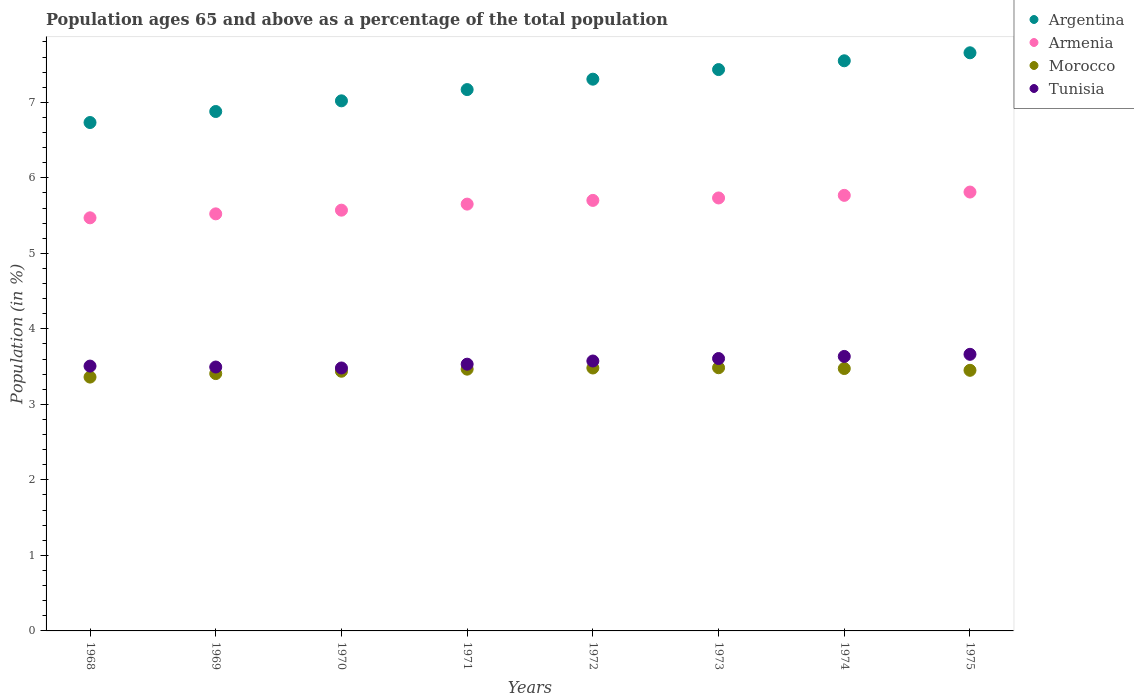What is the percentage of the population ages 65 and above in Argentina in 1972?
Offer a very short reply. 7.31. Across all years, what is the maximum percentage of the population ages 65 and above in Armenia?
Offer a terse response. 5.81. Across all years, what is the minimum percentage of the population ages 65 and above in Tunisia?
Provide a succinct answer. 3.48. In which year was the percentage of the population ages 65 and above in Morocco maximum?
Offer a terse response. 1973. In which year was the percentage of the population ages 65 and above in Tunisia minimum?
Offer a terse response. 1970. What is the total percentage of the population ages 65 and above in Argentina in the graph?
Provide a succinct answer. 57.75. What is the difference between the percentage of the population ages 65 and above in Armenia in 1973 and that in 1975?
Your answer should be very brief. -0.08. What is the difference between the percentage of the population ages 65 and above in Morocco in 1973 and the percentage of the population ages 65 and above in Argentina in 1975?
Make the answer very short. -4.17. What is the average percentage of the population ages 65 and above in Tunisia per year?
Ensure brevity in your answer.  3.56. In the year 1973, what is the difference between the percentage of the population ages 65 and above in Morocco and percentage of the population ages 65 and above in Armenia?
Provide a short and direct response. -2.25. In how many years, is the percentage of the population ages 65 and above in Armenia greater than 6.8?
Give a very brief answer. 0. What is the ratio of the percentage of the population ages 65 and above in Tunisia in 1971 to that in 1974?
Offer a very short reply. 0.97. Is the difference between the percentage of the population ages 65 and above in Morocco in 1970 and 1973 greater than the difference between the percentage of the population ages 65 and above in Armenia in 1970 and 1973?
Make the answer very short. Yes. What is the difference between the highest and the second highest percentage of the population ages 65 and above in Morocco?
Give a very brief answer. 0. What is the difference between the highest and the lowest percentage of the population ages 65 and above in Morocco?
Your answer should be compact. 0.12. Is it the case that in every year, the sum of the percentage of the population ages 65 and above in Armenia and percentage of the population ages 65 and above in Argentina  is greater than the sum of percentage of the population ages 65 and above in Morocco and percentage of the population ages 65 and above in Tunisia?
Offer a terse response. Yes. Does the percentage of the population ages 65 and above in Armenia monotonically increase over the years?
Your answer should be very brief. Yes. Is the percentage of the population ages 65 and above in Tunisia strictly greater than the percentage of the population ages 65 and above in Morocco over the years?
Make the answer very short. Yes. How many years are there in the graph?
Provide a succinct answer. 8. Does the graph contain any zero values?
Your answer should be compact. No. What is the title of the graph?
Make the answer very short. Population ages 65 and above as a percentage of the total population. Does "Malta" appear as one of the legend labels in the graph?
Ensure brevity in your answer.  No. What is the label or title of the Y-axis?
Ensure brevity in your answer.  Population (in %). What is the Population (in %) in Argentina in 1968?
Your answer should be very brief. 6.73. What is the Population (in %) in Armenia in 1968?
Ensure brevity in your answer.  5.47. What is the Population (in %) in Morocco in 1968?
Offer a terse response. 3.36. What is the Population (in %) of Tunisia in 1968?
Your response must be concise. 3.51. What is the Population (in %) in Argentina in 1969?
Provide a succinct answer. 6.88. What is the Population (in %) in Armenia in 1969?
Your response must be concise. 5.52. What is the Population (in %) in Morocco in 1969?
Your response must be concise. 3.41. What is the Population (in %) of Tunisia in 1969?
Offer a very short reply. 3.49. What is the Population (in %) of Argentina in 1970?
Your answer should be compact. 7.02. What is the Population (in %) of Armenia in 1970?
Offer a terse response. 5.57. What is the Population (in %) of Morocco in 1970?
Ensure brevity in your answer.  3.44. What is the Population (in %) in Tunisia in 1970?
Offer a very short reply. 3.48. What is the Population (in %) in Argentina in 1971?
Make the answer very short. 7.17. What is the Population (in %) of Armenia in 1971?
Offer a terse response. 5.65. What is the Population (in %) in Morocco in 1971?
Ensure brevity in your answer.  3.47. What is the Population (in %) in Tunisia in 1971?
Provide a short and direct response. 3.53. What is the Population (in %) of Argentina in 1972?
Your response must be concise. 7.31. What is the Population (in %) in Armenia in 1972?
Make the answer very short. 5.7. What is the Population (in %) of Morocco in 1972?
Ensure brevity in your answer.  3.48. What is the Population (in %) of Tunisia in 1972?
Offer a terse response. 3.57. What is the Population (in %) in Argentina in 1973?
Your response must be concise. 7.43. What is the Population (in %) in Armenia in 1973?
Your answer should be very brief. 5.73. What is the Population (in %) of Morocco in 1973?
Your answer should be very brief. 3.49. What is the Population (in %) of Tunisia in 1973?
Offer a terse response. 3.61. What is the Population (in %) of Argentina in 1974?
Offer a very short reply. 7.55. What is the Population (in %) in Armenia in 1974?
Offer a very short reply. 5.77. What is the Population (in %) in Morocco in 1974?
Your answer should be very brief. 3.47. What is the Population (in %) of Tunisia in 1974?
Your answer should be very brief. 3.63. What is the Population (in %) in Argentina in 1975?
Offer a very short reply. 7.66. What is the Population (in %) of Armenia in 1975?
Ensure brevity in your answer.  5.81. What is the Population (in %) in Morocco in 1975?
Ensure brevity in your answer.  3.45. What is the Population (in %) in Tunisia in 1975?
Offer a very short reply. 3.66. Across all years, what is the maximum Population (in %) of Argentina?
Offer a very short reply. 7.66. Across all years, what is the maximum Population (in %) of Armenia?
Give a very brief answer. 5.81. Across all years, what is the maximum Population (in %) of Morocco?
Keep it short and to the point. 3.49. Across all years, what is the maximum Population (in %) in Tunisia?
Provide a succinct answer. 3.66. Across all years, what is the minimum Population (in %) of Argentina?
Make the answer very short. 6.73. Across all years, what is the minimum Population (in %) of Armenia?
Offer a very short reply. 5.47. Across all years, what is the minimum Population (in %) in Morocco?
Offer a terse response. 3.36. Across all years, what is the minimum Population (in %) in Tunisia?
Keep it short and to the point. 3.48. What is the total Population (in %) in Argentina in the graph?
Offer a very short reply. 57.75. What is the total Population (in %) of Armenia in the graph?
Your answer should be very brief. 45.23. What is the total Population (in %) of Morocco in the graph?
Your response must be concise. 27.57. What is the total Population (in %) of Tunisia in the graph?
Offer a very short reply. 28.5. What is the difference between the Population (in %) in Argentina in 1968 and that in 1969?
Make the answer very short. -0.15. What is the difference between the Population (in %) of Armenia in 1968 and that in 1969?
Give a very brief answer. -0.05. What is the difference between the Population (in %) in Morocco in 1968 and that in 1969?
Your answer should be very brief. -0.05. What is the difference between the Population (in %) of Tunisia in 1968 and that in 1969?
Your answer should be compact. 0.01. What is the difference between the Population (in %) in Argentina in 1968 and that in 1970?
Provide a short and direct response. -0.29. What is the difference between the Population (in %) in Armenia in 1968 and that in 1970?
Your response must be concise. -0.1. What is the difference between the Population (in %) in Morocco in 1968 and that in 1970?
Your response must be concise. -0.08. What is the difference between the Population (in %) in Tunisia in 1968 and that in 1970?
Your response must be concise. 0.03. What is the difference between the Population (in %) in Argentina in 1968 and that in 1971?
Give a very brief answer. -0.44. What is the difference between the Population (in %) of Armenia in 1968 and that in 1971?
Your response must be concise. -0.18. What is the difference between the Population (in %) of Morocco in 1968 and that in 1971?
Your response must be concise. -0.11. What is the difference between the Population (in %) in Tunisia in 1968 and that in 1971?
Keep it short and to the point. -0.03. What is the difference between the Population (in %) of Argentina in 1968 and that in 1972?
Ensure brevity in your answer.  -0.57. What is the difference between the Population (in %) in Armenia in 1968 and that in 1972?
Your answer should be compact. -0.23. What is the difference between the Population (in %) of Morocco in 1968 and that in 1972?
Offer a very short reply. -0.12. What is the difference between the Population (in %) in Tunisia in 1968 and that in 1972?
Offer a terse response. -0.07. What is the difference between the Population (in %) of Argentina in 1968 and that in 1973?
Make the answer very short. -0.7. What is the difference between the Population (in %) of Armenia in 1968 and that in 1973?
Provide a succinct answer. -0.26. What is the difference between the Population (in %) of Morocco in 1968 and that in 1973?
Your answer should be very brief. -0.12. What is the difference between the Population (in %) of Tunisia in 1968 and that in 1973?
Provide a succinct answer. -0.1. What is the difference between the Population (in %) in Argentina in 1968 and that in 1974?
Give a very brief answer. -0.82. What is the difference between the Population (in %) in Armenia in 1968 and that in 1974?
Your answer should be compact. -0.3. What is the difference between the Population (in %) of Morocco in 1968 and that in 1974?
Offer a very short reply. -0.11. What is the difference between the Population (in %) in Tunisia in 1968 and that in 1974?
Make the answer very short. -0.13. What is the difference between the Population (in %) in Argentina in 1968 and that in 1975?
Ensure brevity in your answer.  -0.92. What is the difference between the Population (in %) of Armenia in 1968 and that in 1975?
Provide a succinct answer. -0.34. What is the difference between the Population (in %) in Morocco in 1968 and that in 1975?
Keep it short and to the point. -0.09. What is the difference between the Population (in %) in Tunisia in 1968 and that in 1975?
Your answer should be compact. -0.16. What is the difference between the Population (in %) in Argentina in 1969 and that in 1970?
Make the answer very short. -0.14. What is the difference between the Population (in %) in Armenia in 1969 and that in 1970?
Provide a succinct answer. -0.05. What is the difference between the Population (in %) of Morocco in 1969 and that in 1970?
Offer a terse response. -0.03. What is the difference between the Population (in %) of Tunisia in 1969 and that in 1970?
Your response must be concise. 0.01. What is the difference between the Population (in %) in Argentina in 1969 and that in 1971?
Offer a very short reply. -0.29. What is the difference between the Population (in %) of Armenia in 1969 and that in 1971?
Keep it short and to the point. -0.13. What is the difference between the Population (in %) of Morocco in 1969 and that in 1971?
Ensure brevity in your answer.  -0.06. What is the difference between the Population (in %) in Tunisia in 1969 and that in 1971?
Provide a short and direct response. -0.04. What is the difference between the Population (in %) in Argentina in 1969 and that in 1972?
Provide a succinct answer. -0.43. What is the difference between the Population (in %) in Armenia in 1969 and that in 1972?
Offer a very short reply. -0.18. What is the difference between the Population (in %) in Morocco in 1969 and that in 1972?
Keep it short and to the point. -0.07. What is the difference between the Population (in %) in Tunisia in 1969 and that in 1972?
Make the answer very short. -0.08. What is the difference between the Population (in %) in Argentina in 1969 and that in 1973?
Make the answer very short. -0.56. What is the difference between the Population (in %) in Armenia in 1969 and that in 1973?
Your answer should be compact. -0.21. What is the difference between the Population (in %) of Morocco in 1969 and that in 1973?
Keep it short and to the point. -0.08. What is the difference between the Population (in %) of Tunisia in 1969 and that in 1973?
Provide a succinct answer. -0.11. What is the difference between the Population (in %) in Argentina in 1969 and that in 1974?
Provide a succinct answer. -0.67. What is the difference between the Population (in %) of Armenia in 1969 and that in 1974?
Provide a short and direct response. -0.24. What is the difference between the Population (in %) of Morocco in 1969 and that in 1974?
Give a very brief answer. -0.07. What is the difference between the Population (in %) of Tunisia in 1969 and that in 1974?
Offer a very short reply. -0.14. What is the difference between the Population (in %) of Argentina in 1969 and that in 1975?
Your answer should be very brief. -0.78. What is the difference between the Population (in %) of Armenia in 1969 and that in 1975?
Your response must be concise. -0.29. What is the difference between the Population (in %) of Morocco in 1969 and that in 1975?
Give a very brief answer. -0.04. What is the difference between the Population (in %) of Tunisia in 1969 and that in 1975?
Keep it short and to the point. -0.17. What is the difference between the Population (in %) in Argentina in 1970 and that in 1971?
Make the answer very short. -0.15. What is the difference between the Population (in %) in Armenia in 1970 and that in 1971?
Provide a succinct answer. -0.08. What is the difference between the Population (in %) in Morocco in 1970 and that in 1971?
Provide a succinct answer. -0.03. What is the difference between the Population (in %) of Tunisia in 1970 and that in 1971?
Offer a terse response. -0.05. What is the difference between the Population (in %) in Argentina in 1970 and that in 1972?
Your response must be concise. -0.29. What is the difference between the Population (in %) of Armenia in 1970 and that in 1972?
Offer a terse response. -0.13. What is the difference between the Population (in %) in Morocco in 1970 and that in 1972?
Provide a short and direct response. -0.04. What is the difference between the Population (in %) of Tunisia in 1970 and that in 1972?
Keep it short and to the point. -0.09. What is the difference between the Population (in %) of Argentina in 1970 and that in 1973?
Keep it short and to the point. -0.41. What is the difference between the Population (in %) of Armenia in 1970 and that in 1973?
Your answer should be very brief. -0.16. What is the difference between the Population (in %) of Morocco in 1970 and that in 1973?
Make the answer very short. -0.05. What is the difference between the Population (in %) of Tunisia in 1970 and that in 1973?
Ensure brevity in your answer.  -0.13. What is the difference between the Population (in %) of Argentina in 1970 and that in 1974?
Your answer should be compact. -0.53. What is the difference between the Population (in %) in Armenia in 1970 and that in 1974?
Your answer should be very brief. -0.2. What is the difference between the Population (in %) in Morocco in 1970 and that in 1974?
Give a very brief answer. -0.04. What is the difference between the Population (in %) in Tunisia in 1970 and that in 1974?
Give a very brief answer. -0.15. What is the difference between the Population (in %) of Argentina in 1970 and that in 1975?
Give a very brief answer. -0.64. What is the difference between the Population (in %) in Armenia in 1970 and that in 1975?
Give a very brief answer. -0.24. What is the difference between the Population (in %) of Morocco in 1970 and that in 1975?
Provide a succinct answer. -0.01. What is the difference between the Population (in %) in Tunisia in 1970 and that in 1975?
Give a very brief answer. -0.18. What is the difference between the Population (in %) of Argentina in 1971 and that in 1972?
Make the answer very short. -0.14. What is the difference between the Population (in %) in Armenia in 1971 and that in 1972?
Your response must be concise. -0.05. What is the difference between the Population (in %) in Morocco in 1971 and that in 1972?
Provide a succinct answer. -0.02. What is the difference between the Population (in %) of Tunisia in 1971 and that in 1972?
Provide a succinct answer. -0.04. What is the difference between the Population (in %) in Argentina in 1971 and that in 1973?
Provide a short and direct response. -0.27. What is the difference between the Population (in %) of Armenia in 1971 and that in 1973?
Ensure brevity in your answer.  -0.08. What is the difference between the Population (in %) of Morocco in 1971 and that in 1973?
Provide a succinct answer. -0.02. What is the difference between the Population (in %) of Tunisia in 1971 and that in 1973?
Your answer should be compact. -0.07. What is the difference between the Population (in %) of Argentina in 1971 and that in 1974?
Make the answer very short. -0.38. What is the difference between the Population (in %) in Armenia in 1971 and that in 1974?
Keep it short and to the point. -0.12. What is the difference between the Population (in %) of Morocco in 1971 and that in 1974?
Your response must be concise. -0.01. What is the difference between the Population (in %) of Tunisia in 1971 and that in 1974?
Provide a succinct answer. -0.1. What is the difference between the Population (in %) of Argentina in 1971 and that in 1975?
Provide a short and direct response. -0.49. What is the difference between the Population (in %) of Armenia in 1971 and that in 1975?
Keep it short and to the point. -0.16. What is the difference between the Population (in %) in Morocco in 1971 and that in 1975?
Your answer should be compact. 0.02. What is the difference between the Population (in %) of Tunisia in 1971 and that in 1975?
Give a very brief answer. -0.13. What is the difference between the Population (in %) in Argentina in 1972 and that in 1973?
Offer a terse response. -0.13. What is the difference between the Population (in %) in Armenia in 1972 and that in 1973?
Offer a terse response. -0.03. What is the difference between the Population (in %) in Morocco in 1972 and that in 1973?
Make the answer very short. -0. What is the difference between the Population (in %) in Tunisia in 1972 and that in 1973?
Offer a terse response. -0.03. What is the difference between the Population (in %) of Argentina in 1972 and that in 1974?
Offer a very short reply. -0.24. What is the difference between the Population (in %) of Armenia in 1972 and that in 1974?
Keep it short and to the point. -0.07. What is the difference between the Population (in %) of Morocco in 1972 and that in 1974?
Provide a short and direct response. 0.01. What is the difference between the Population (in %) of Tunisia in 1972 and that in 1974?
Provide a succinct answer. -0.06. What is the difference between the Population (in %) in Argentina in 1972 and that in 1975?
Your response must be concise. -0.35. What is the difference between the Population (in %) of Armenia in 1972 and that in 1975?
Your answer should be very brief. -0.11. What is the difference between the Population (in %) in Morocco in 1972 and that in 1975?
Ensure brevity in your answer.  0.03. What is the difference between the Population (in %) of Tunisia in 1972 and that in 1975?
Offer a terse response. -0.09. What is the difference between the Population (in %) in Argentina in 1973 and that in 1974?
Give a very brief answer. -0.12. What is the difference between the Population (in %) in Armenia in 1973 and that in 1974?
Make the answer very short. -0.03. What is the difference between the Population (in %) of Morocco in 1973 and that in 1974?
Offer a terse response. 0.01. What is the difference between the Population (in %) in Tunisia in 1973 and that in 1974?
Make the answer very short. -0.03. What is the difference between the Population (in %) in Argentina in 1973 and that in 1975?
Offer a terse response. -0.22. What is the difference between the Population (in %) in Armenia in 1973 and that in 1975?
Give a very brief answer. -0.08. What is the difference between the Population (in %) of Morocco in 1973 and that in 1975?
Give a very brief answer. 0.03. What is the difference between the Population (in %) in Tunisia in 1973 and that in 1975?
Give a very brief answer. -0.06. What is the difference between the Population (in %) of Argentina in 1974 and that in 1975?
Give a very brief answer. -0.11. What is the difference between the Population (in %) in Armenia in 1974 and that in 1975?
Offer a terse response. -0.04. What is the difference between the Population (in %) of Morocco in 1974 and that in 1975?
Ensure brevity in your answer.  0.02. What is the difference between the Population (in %) in Tunisia in 1974 and that in 1975?
Your answer should be very brief. -0.03. What is the difference between the Population (in %) in Argentina in 1968 and the Population (in %) in Armenia in 1969?
Your answer should be very brief. 1.21. What is the difference between the Population (in %) of Argentina in 1968 and the Population (in %) of Morocco in 1969?
Offer a terse response. 3.32. What is the difference between the Population (in %) of Argentina in 1968 and the Population (in %) of Tunisia in 1969?
Your answer should be compact. 3.24. What is the difference between the Population (in %) in Armenia in 1968 and the Population (in %) in Morocco in 1969?
Provide a short and direct response. 2.06. What is the difference between the Population (in %) of Armenia in 1968 and the Population (in %) of Tunisia in 1969?
Offer a terse response. 1.98. What is the difference between the Population (in %) in Morocco in 1968 and the Population (in %) in Tunisia in 1969?
Keep it short and to the point. -0.13. What is the difference between the Population (in %) in Argentina in 1968 and the Population (in %) in Armenia in 1970?
Make the answer very short. 1.16. What is the difference between the Population (in %) of Argentina in 1968 and the Population (in %) of Morocco in 1970?
Provide a short and direct response. 3.29. What is the difference between the Population (in %) of Argentina in 1968 and the Population (in %) of Tunisia in 1970?
Provide a short and direct response. 3.25. What is the difference between the Population (in %) of Armenia in 1968 and the Population (in %) of Morocco in 1970?
Offer a terse response. 2.03. What is the difference between the Population (in %) of Armenia in 1968 and the Population (in %) of Tunisia in 1970?
Provide a short and direct response. 1.99. What is the difference between the Population (in %) in Morocco in 1968 and the Population (in %) in Tunisia in 1970?
Provide a succinct answer. -0.12. What is the difference between the Population (in %) in Argentina in 1968 and the Population (in %) in Armenia in 1971?
Offer a very short reply. 1.08. What is the difference between the Population (in %) of Argentina in 1968 and the Population (in %) of Morocco in 1971?
Offer a terse response. 3.27. What is the difference between the Population (in %) in Argentina in 1968 and the Population (in %) in Tunisia in 1971?
Offer a very short reply. 3.2. What is the difference between the Population (in %) in Armenia in 1968 and the Population (in %) in Morocco in 1971?
Your answer should be compact. 2. What is the difference between the Population (in %) in Armenia in 1968 and the Population (in %) in Tunisia in 1971?
Provide a short and direct response. 1.94. What is the difference between the Population (in %) of Morocco in 1968 and the Population (in %) of Tunisia in 1971?
Offer a very short reply. -0.17. What is the difference between the Population (in %) of Argentina in 1968 and the Population (in %) of Armenia in 1972?
Ensure brevity in your answer.  1.03. What is the difference between the Population (in %) in Argentina in 1968 and the Population (in %) in Morocco in 1972?
Offer a very short reply. 3.25. What is the difference between the Population (in %) in Argentina in 1968 and the Population (in %) in Tunisia in 1972?
Your response must be concise. 3.16. What is the difference between the Population (in %) in Armenia in 1968 and the Population (in %) in Morocco in 1972?
Provide a short and direct response. 1.99. What is the difference between the Population (in %) in Armenia in 1968 and the Population (in %) in Tunisia in 1972?
Your answer should be compact. 1.9. What is the difference between the Population (in %) of Morocco in 1968 and the Population (in %) of Tunisia in 1972?
Your answer should be very brief. -0.21. What is the difference between the Population (in %) in Argentina in 1968 and the Population (in %) in Armenia in 1973?
Provide a short and direct response. 1. What is the difference between the Population (in %) in Argentina in 1968 and the Population (in %) in Morocco in 1973?
Your answer should be compact. 3.25. What is the difference between the Population (in %) of Argentina in 1968 and the Population (in %) of Tunisia in 1973?
Offer a very short reply. 3.13. What is the difference between the Population (in %) in Armenia in 1968 and the Population (in %) in Morocco in 1973?
Offer a very short reply. 1.99. What is the difference between the Population (in %) in Armenia in 1968 and the Population (in %) in Tunisia in 1973?
Your answer should be compact. 1.86. What is the difference between the Population (in %) of Morocco in 1968 and the Population (in %) of Tunisia in 1973?
Give a very brief answer. -0.25. What is the difference between the Population (in %) in Argentina in 1968 and the Population (in %) in Armenia in 1974?
Provide a succinct answer. 0.96. What is the difference between the Population (in %) in Argentina in 1968 and the Population (in %) in Morocco in 1974?
Make the answer very short. 3.26. What is the difference between the Population (in %) in Argentina in 1968 and the Population (in %) in Tunisia in 1974?
Provide a succinct answer. 3.1. What is the difference between the Population (in %) of Armenia in 1968 and the Population (in %) of Morocco in 1974?
Your response must be concise. 2. What is the difference between the Population (in %) in Armenia in 1968 and the Population (in %) in Tunisia in 1974?
Keep it short and to the point. 1.84. What is the difference between the Population (in %) of Morocco in 1968 and the Population (in %) of Tunisia in 1974?
Your answer should be very brief. -0.27. What is the difference between the Population (in %) of Argentina in 1968 and the Population (in %) of Armenia in 1975?
Ensure brevity in your answer.  0.92. What is the difference between the Population (in %) of Argentina in 1968 and the Population (in %) of Morocco in 1975?
Provide a succinct answer. 3.28. What is the difference between the Population (in %) in Argentina in 1968 and the Population (in %) in Tunisia in 1975?
Your response must be concise. 3.07. What is the difference between the Population (in %) in Armenia in 1968 and the Population (in %) in Morocco in 1975?
Your answer should be very brief. 2.02. What is the difference between the Population (in %) of Armenia in 1968 and the Population (in %) of Tunisia in 1975?
Provide a short and direct response. 1.81. What is the difference between the Population (in %) in Morocco in 1968 and the Population (in %) in Tunisia in 1975?
Provide a succinct answer. -0.3. What is the difference between the Population (in %) of Argentina in 1969 and the Population (in %) of Armenia in 1970?
Your response must be concise. 1.31. What is the difference between the Population (in %) in Argentina in 1969 and the Population (in %) in Morocco in 1970?
Give a very brief answer. 3.44. What is the difference between the Population (in %) of Argentina in 1969 and the Population (in %) of Tunisia in 1970?
Ensure brevity in your answer.  3.4. What is the difference between the Population (in %) of Armenia in 1969 and the Population (in %) of Morocco in 1970?
Your answer should be very brief. 2.08. What is the difference between the Population (in %) of Armenia in 1969 and the Population (in %) of Tunisia in 1970?
Give a very brief answer. 2.04. What is the difference between the Population (in %) of Morocco in 1969 and the Population (in %) of Tunisia in 1970?
Give a very brief answer. -0.07. What is the difference between the Population (in %) of Argentina in 1969 and the Population (in %) of Armenia in 1971?
Your answer should be very brief. 1.23. What is the difference between the Population (in %) in Argentina in 1969 and the Population (in %) in Morocco in 1971?
Give a very brief answer. 3.41. What is the difference between the Population (in %) in Argentina in 1969 and the Population (in %) in Tunisia in 1971?
Your response must be concise. 3.35. What is the difference between the Population (in %) in Armenia in 1969 and the Population (in %) in Morocco in 1971?
Ensure brevity in your answer.  2.06. What is the difference between the Population (in %) of Armenia in 1969 and the Population (in %) of Tunisia in 1971?
Offer a terse response. 1.99. What is the difference between the Population (in %) of Morocco in 1969 and the Population (in %) of Tunisia in 1971?
Keep it short and to the point. -0.12. What is the difference between the Population (in %) of Argentina in 1969 and the Population (in %) of Armenia in 1972?
Keep it short and to the point. 1.18. What is the difference between the Population (in %) in Argentina in 1969 and the Population (in %) in Morocco in 1972?
Give a very brief answer. 3.4. What is the difference between the Population (in %) in Argentina in 1969 and the Population (in %) in Tunisia in 1972?
Ensure brevity in your answer.  3.3. What is the difference between the Population (in %) of Armenia in 1969 and the Population (in %) of Morocco in 1972?
Your response must be concise. 2.04. What is the difference between the Population (in %) in Armenia in 1969 and the Population (in %) in Tunisia in 1972?
Provide a succinct answer. 1.95. What is the difference between the Population (in %) in Morocco in 1969 and the Population (in %) in Tunisia in 1972?
Provide a succinct answer. -0.17. What is the difference between the Population (in %) in Argentina in 1969 and the Population (in %) in Armenia in 1973?
Give a very brief answer. 1.14. What is the difference between the Population (in %) in Argentina in 1969 and the Population (in %) in Morocco in 1973?
Your answer should be very brief. 3.39. What is the difference between the Population (in %) in Argentina in 1969 and the Population (in %) in Tunisia in 1973?
Ensure brevity in your answer.  3.27. What is the difference between the Population (in %) in Armenia in 1969 and the Population (in %) in Morocco in 1973?
Make the answer very short. 2.04. What is the difference between the Population (in %) in Armenia in 1969 and the Population (in %) in Tunisia in 1973?
Provide a short and direct response. 1.92. What is the difference between the Population (in %) in Morocco in 1969 and the Population (in %) in Tunisia in 1973?
Your response must be concise. -0.2. What is the difference between the Population (in %) of Argentina in 1969 and the Population (in %) of Armenia in 1974?
Provide a succinct answer. 1.11. What is the difference between the Population (in %) in Argentina in 1969 and the Population (in %) in Morocco in 1974?
Your answer should be compact. 3.4. What is the difference between the Population (in %) in Argentina in 1969 and the Population (in %) in Tunisia in 1974?
Your answer should be very brief. 3.24. What is the difference between the Population (in %) in Armenia in 1969 and the Population (in %) in Morocco in 1974?
Your answer should be very brief. 2.05. What is the difference between the Population (in %) of Armenia in 1969 and the Population (in %) of Tunisia in 1974?
Your answer should be compact. 1.89. What is the difference between the Population (in %) of Morocco in 1969 and the Population (in %) of Tunisia in 1974?
Your response must be concise. -0.23. What is the difference between the Population (in %) of Argentina in 1969 and the Population (in %) of Armenia in 1975?
Ensure brevity in your answer.  1.07. What is the difference between the Population (in %) in Argentina in 1969 and the Population (in %) in Morocco in 1975?
Provide a short and direct response. 3.43. What is the difference between the Population (in %) of Argentina in 1969 and the Population (in %) of Tunisia in 1975?
Ensure brevity in your answer.  3.22. What is the difference between the Population (in %) of Armenia in 1969 and the Population (in %) of Morocco in 1975?
Ensure brevity in your answer.  2.07. What is the difference between the Population (in %) of Armenia in 1969 and the Population (in %) of Tunisia in 1975?
Ensure brevity in your answer.  1.86. What is the difference between the Population (in %) in Morocco in 1969 and the Population (in %) in Tunisia in 1975?
Offer a terse response. -0.26. What is the difference between the Population (in %) of Argentina in 1970 and the Population (in %) of Armenia in 1971?
Your response must be concise. 1.37. What is the difference between the Population (in %) in Argentina in 1970 and the Population (in %) in Morocco in 1971?
Provide a succinct answer. 3.55. What is the difference between the Population (in %) in Argentina in 1970 and the Population (in %) in Tunisia in 1971?
Provide a succinct answer. 3.49. What is the difference between the Population (in %) of Armenia in 1970 and the Population (in %) of Morocco in 1971?
Make the answer very short. 2.11. What is the difference between the Population (in %) of Armenia in 1970 and the Population (in %) of Tunisia in 1971?
Your answer should be very brief. 2.04. What is the difference between the Population (in %) of Morocco in 1970 and the Population (in %) of Tunisia in 1971?
Provide a succinct answer. -0.09. What is the difference between the Population (in %) of Argentina in 1970 and the Population (in %) of Armenia in 1972?
Provide a succinct answer. 1.32. What is the difference between the Population (in %) in Argentina in 1970 and the Population (in %) in Morocco in 1972?
Your answer should be compact. 3.54. What is the difference between the Population (in %) of Argentina in 1970 and the Population (in %) of Tunisia in 1972?
Your answer should be compact. 3.45. What is the difference between the Population (in %) of Armenia in 1970 and the Population (in %) of Morocco in 1972?
Offer a terse response. 2.09. What is the difference between the Population (in %) of Armenia in 1970 and the Population (in %) of Tunisia in 1972?
Your answer should be very brief. 2. What is the difference between the Population (in %) of Morocco in 1970 and the Population (in %) of Tunisia in 1972?
Keep it short and to the point. -0.14. What is the difference between the Population (in %) of Argentina in 1970 and the Population (in %) of Armenia in 1973?
Provide a succinct answer. 1.29. What is the difference between the Population (in %) of Argentina in 1970 and the Population (in %) of Morocco in 1973?
Your answer should be very brief. 3.53. What is the difference between the Population (in %) in Argentina in 1970 and the Population (in %) in Tunisia in 1973?
Your response must be concise. 3.41. What is the difference between the Population (in %) of Armenia in 1970 and the Population (in %) of Morocco in 1973?
Your answer should be very brief. 2.09. What is the difference between the Population (in %) of Armenia in 1970 and the Population (in %) of Tunisia in 1973?
Your response must be concise. 1.96. What is the difference between the Population (in %) in Morocco in 1970 and the Population (in %) in Tunisia in 1973?
Make the answer very short. -0.17. What is the difference between the Population (in %) of Argentina in 1970 and the Population (in %) of Armenia in 1974?
Your response must be concise. 1.25. What is the difference between the Population (in %) of Argentina in 1970 and the Population (in %) of Morocco in 1974?
Provide a succinct answer. 3.54. What is the difference between the Population (in %) in Argentina in 1970 and the Population (in %) in Tunisia in 1974?
Provide a short and direct response. 3.38. What is the difference between the Population (in %) of Armenia in 1970 and the Population (in %) of Morocco in 1974?
Offer a terse response. 2.1. What is the difference between the Population (in %) of Armenia in 1970 and the Population (in %) of Tunisia in 1974?
Ensure brevity in your answer.  1.94. What is the difference between the Population (in %) in Morocco in 1970 and the Population (in %) in Tunisia in 1974?
Give a very brief answer. -0.2. What is the difference between the Population (in %) in Argentina in 1970 and the Population (in %) in Armenia in 1975?
Offer a terse response. 1.21. What is the difference between the Population (in %) of Argentina in 1970 and the Population (in %) of Morocco in 1975?
Give a very brief answer. 3.57. What is the difference between the Population (in %) in Argentina in 1970 and the Population (in %) in Tunisia in 1975?
Keep it short and to the point. 3.36. What is the difference between the Population (in %) of Armenia in 1970 and the Population (in %) of Morocco in 1975?
Your response must be concise. 2.12. What is the difference between the Population (in %) of Armenia in 1970 and the Population (in %) of Tunisia in 1975?
Ensure brevity in your answer.  1.91. What is the difference between the Population (in %) in Morocco in 1970 and the Population (in %) in Tunisia in 1975?
Your response must be concise. -0.22. What is the difference between the Population (in %) of Argentina in 1971 and the Population (in %) of Armenia in 1972?
Offer a very short reply. 1.47. What is the difference between the Population (in %) in Argentina in 1971 and the Population (in %) in Morocco in 1972?
Your answer should be very brief. 3.69. What is the difference between the Population (in %) of Argentina in 1971 and the Population (in %) of Tunisia in 1972?
Ensure brevity in your answer.  3.59. What is the difference between the Population (in %) in Armenia in 1971 and the Population (in %) in Morocco in 1972?
Your response must be concise. 2.17. What is the difference between the Population (in %) of Armenia in 1971 and the Population (in %) of Tunisia in 1972?
Your answer should be very brief. 2.08. What is the difference between the Population (in %) of Morocco in 1971 and the Population (in %) of Tunisia in 1972?
Your answer should be compact. -0.11. What is the difference between the Population (in %) in Argentina in 1971 and the Population (in %) in Armenia in 1973?
Offer a terse response. 1.44. What is the difference between the Population (in %) in Argentina in 1971 and the Population (in %) in Morocco in 1973?
Give a very brief answer. 3.68. What is the difference between the Population (in %) in Argentina in 1971 and the Population (in %) in Tunisia in 1973?
Provide a short and direct response. 3.56. What is the difference between the Population (in %) in Armenia in 1971 and the Population (in %) in Morocco in 1973?
Offer a terse response. 2.17. What is the difference between the Population (in %) of Armenia in 1971 and the Population (in %) of Tunisia in 1973?
Offer a very short reply. 2.04. What is the difference between the Population (in %) in Morocco in 1971 and the Population (in %) in Tunisia in 1973?
Offer a terse response. -0.14. What is the difference between the Population (in %) of Argentina in 1971 and the Population (in %) of Armenia in 1974?
Offer a very short reply. 1.4. What is the difference between the Population (in %) of Argentina in 1971 and the Population (in %) of Morocco in 1974?
Offer a terse response. 3.69. What is the difference between the Population (in %) of Argentina in 1971 and the Population (in %) of Tunisia in 1974?
Provide a succinct answer. 3.53. What is the difference between the Population (in %) in Armenia in 1971 and the Population (in %) in Morocco in 1974?
Keep it short and to the point. 2.18. What is the difference between the Population (in %) of Armenia in 1971 and the Population (in %) of Tunisia in 1974?
Make the answer very short. 2.02. What is the difference between the Population (in %) in Morocco in 1971 and the Population (in %) in Tunisia in 1974?
Make the answer very short. -0.17. What is the difference between the Population (in %) in Argentina in 1971 and the Population (in %) in Armenia in 1975?
Provide a short and direct response. 1.36. What is the difference between the Population (in %) of Argentina in 1971 and the Population (in %) of Morocco in 1975?
Make the answer very short. 3.72. What is the difference between the Population (in %) in Argentina in 1971 and the Population (in %) in Tunisia in 1975?
Your answer should be compact. 3.51. What is the difference between the Population (in %) in Armenia in 1971 and the Population (in %) in Morocco in 1975?
Your response must be concise. 2.2. What is the difference between the Population (in %) of Armenia in 1971 and the Population (in %) of Tunisia in 1975?
Keep it short and to the point. 1.99. What is the difference between the Population (in %) in Morocco in 1971 and the Population (in %) in Tunisia in 1975?
Offer a terse response. -0.2. What is the difference between the Population (in %) in Argentina in 1972 and the Population (in %) in Armenia in 1973?
Provide a short and direct response. 1.57. What is the difference between the Population (in %) of Argentina in 1972 and the Population (in %) of Morocco in 1973?
Offer a terse response. 3.82. What is the difference between the Population (in %) in Argentina in 1972 and the Population (in %) in Tunisia in 1973?
Your response must be concise. 3.7. What is the difference between the Population (in %) of Armenia in 1972 and the Population (in %) of Morocco in 1973?
Your answer should be very brief. 2.22. What is the difference between the Population (in %) in Armenia in 1972 and the Population (in %) in Tunisia in 1973?
Provide a short and direct response. 2.09. What is the difference between the Population (in %) of Morocco in 1972 and the Population (in %) of Tunisia in 1973?
Provide a short and direct response. -0.13. What is the difference between the Population (in %) of Argentina in 1972 and the Population (in %) of Armenia in 1974?
Provide a short and direct response. 1.54. What is the difference between the Population (in %) of Argentina in 1972 and the Population (in %) of Morocco in 1974?
Make the answer very short. 3.83. What is the difference between the Population (in %) of Argentina in 1972 and the Population (in %) of Tunisia in 1974?
Your answer should be very brief. 3.67. What is the difference between the Population (in %) of Armenia in 1972 and the Population (in %) of Morocco in 1974?
Provide a succinct answer. 2.23. What is the difference between the Population (in %) in Armenia in 1972 and the Population (in %) in Tunisia in 1974?
Offer a very short reply. 2.07. What is the difference between the Population (in %) of Morocco in 1972 and the Population (in %) of Tunisia in 1974?
Your answer should be very brief. -0.15. What is the difference between the Population (in %) in Argentina in 1972 and the Population (in %) in Armenia in 1975?
Your answer should be very brief. 1.49. What is the difference between the Population (in %) of Argentina in 1972 and the Population (in %) of Morocco in 1975?
Provide a succinct answer. 3.86. What is the difference between the Population (in %) of Argentina in 1972 and the Population (in %) of Tunisia in 1975?
Provide a succinct answer. 3.64. What is the difference between the Population (in %) in Armenia in 1972 and the Population (in %) in Morocco in 1975?
Provide a succinct answer. 2.25. What is the difference between the Population (in %) in Armenia in 1972 and the Population (in %) in Tunisia in 1975?
Provide a short and direct response. 2.04. What is the difference between the Population (in %) in Morocco in 1972 and the Population (in %) in Tunisia in 1975?
Offer a very short reply. -0.18. What is the difference between the Population (in %) in Argentina in 1973 and the Population (in %) in Armenia in 1974?
Ensure brevity in your answer.  1.67. What is the difference between the Population (in %) in Argentina in 1973 and the Population (in %) in Morocco in 1974?
Ensure brevity in your answer.  3.96. What is the difference between the Population (in %) in Argentina in 1973 and the Population (in %) in Tunisia in 1974?
Provide a succinct answer. 3.8. What is the difference between the Population (in %) in Armenia in 1973 and the Population (in %) in Morocco in 1974?
Make the answer very short. 2.26. What is the difference between the Population (in %) in Armenia in 1973 and the Population (in %) in Tunisia in 1974?
Offer a terse response. 2.1. What is the difference between the Population (in %) in Morocco in 1973 and the Population (in %) in Tunisia in 1974?
Make the answer very short. -0.15. What is the difference between the Population (in %) of Argentina in 1973 and the Population (in %) of Armenia in 1975?
Give a very brief answer. 1.62. What is the difference between the Population (in %) of Argentina in 1973 and the Population (in %) of Morocco in 1975?
Offer a terse response. 3.98. What is the difference between the Population (in %) of Argentina in 1973 and the Population (in %) of Tunisia in 1975?
Make the answer very short. 3.77. What is the difference between the Population (in %) in Armenia in 1973 and the Population (in %) in Morocco in 1975?
Offer a terse response. 2.28. What is the difference between the Population (in %) in Armenia in 1973 and the Population (in %) in Tunisia in 1975?
Provide a succinct answer. 2.07. What is the difference between the Population (in %) in Morocco in 1973 and the Population (in %) in Tunisia in 1975?
Give a very brief answer. -0.18. What is the difference between the Population (in %) in Argentina in 1974 and the Population (in %) in Armenia in 1975?
Give a very brief answer. 1.74. What is the difference between the Population (in %) of Argentina in 1974 and the Population (in %) of Morocco in 1975?
Provide a short and direct response. 4.1. What is the difference between the Population (in %) of Argentina in 1974 and the Population (in %) of Tunisia in 1975?
Provide a succinct answer. 3.89. What is the difference between the Population (in %) in Armenia in 1974 and the Population (in %) in Morocco in 1975?
Make the answer very short. 2.32. What is the difference between the Population (in %) in Armenia in 1974 and the Population (in %) in Tunisia in 1975?
Your answer should be very brief. 2.11. What is the difference between the Population (in %) of Morocco in 1974 and the Population (in %) of Tunisia in 1975?
Give a very brief answer. -0.19. What is the average Population (in %) in Argentina per year?
Provide a succinct answer. 7.22. What is the average Population (in %) of Armenia per year?
Your answer should be very brief. 5.65. What is the average Population (in %) in Morocco per year?
Give a very brief answer. 3.45. What is the average Population (in %) in Tunisia per year?
Offer a terse response. 3.56. In the year 1968, what is the difference between the Population (in %) of Argentina and Population (in %) of Armenia?
Ensure brevity in your answer.  1.26. In the year 1968, what is the difference between the Population (in %) of Argentina and Population (in %) of Morocco?
Provide a succinct answer. 3.37. In the year 1968, what is the difference between the Population (in %) in Argentina and Population (in %) in Tunisia?
Provide a succinct answer. 3.23. In the year 1968, what is the difference between the Population (in %) of Armenia and Population (in %) of Morocco?
Offer a very short reply. 2.11. In the year 1968, what is the difference between the Population (in %) of Armenia and Population (in %) of Tunisia?
Give a very brief answer. 1.96. In the year 1968, what is the difference between the Population (in %) in Morocco and Population (in %) in Tunisia?
Offer a very short reply. -0.15. In the year 1969, what is the difference between the Population (in %) in Argentina and Population (in %) in Armenia?
Give a very brief answer. 1.36. In the year 1969, what is the difference between the Population (in %) of Argentina and Population (in %) of Morocco?
Your answer should be very brief. 3.47. In the year 1969, what is the difference between the Population (in %) in Argentina and Population (in %) in Tunisia?
Offer a very short reply. 3.38. In the year 1969, what is the difference between the Population (in %) in Armenia and Population (in %) in Morocco?
Make the answer very short. 2.12. In the year 1969, what is the difference between the Population (in %) of Armenia and Population (in %) of Tunisia?
Your response must be concise. 2.03. In the year 1969, what is the difference between the Population (in %) of Morocco and Population (in %) of Tunisia?
Ensure brevity in your answer.  -0.09. In the year 1970, what is the difference between the Population (in %) of Argentina and Population (in %) of Armenia?
Your answer should be compact. 1.45. In the year 1970, what is the difference between the Population (in %) of Argentina and Population (in %) of Morocco?
Offer a terse response. 3.58. In the year 1970, what is the difference between the Population (in %) of Argentina and Population (in %) of Tunisia?
Provide a succinct answer. 3.54. In the year 1970, what is the difference between the Population (in %) of Armenia and Population (in %) of Morocco?
Offer a terse response. 2.13. In the year 1970, what is the difference between the Population (in %) of Armenia and Population (in %) of Tunisia?
Make the answer very short. 2.09. In the year 1970, what is the difference between the Population (in %) in Morocco and Population (in %) in Tunisia?
Your response must be concise. -0.04. In the year 1971, what is the difference between the Population (in %) of Argentina and Population (in %) of Armenia?
Keep it short and to the point. 1.52. In the year 1971, what is the difference between the Population (in %) of Argentina and Population (in %) of Morocco?
Make the answer very short. 3.7. In the year 1971, what is the difference between the Population (in %) in Argentina and Population (in %) in Tunisia?
Provide a succinct answer. 3.64. In the year 1971, what is the difference between the Population (in %) in Armenia and Population (in %) in Morocco?
Provide a short and direct response. 2.19. In the year 1971, what is the difference between the Population (in %) in Armenia and Population (in %) in Tunisia?
Your response must be concise. 2.12. In the year 1971, what is the difference between the Population (in %) of Morocco and Population (in %) of Tunisia?
Provide a succinct answer. -0.07. In the year 1972, what is the difference between the Population (in %) in Argentina and Population (in %) in Armenia?
Your answer should be very brief. 1.61. In the year 1972, what is the difference between the Population (in %) of Argentina and Population (in %) of Morocco?
Give a very brief answer. 3.82. In the year 1972, what is the difference between the Population (in %) in Argentina and Population (in %) in Tunisia?
Offer a very short reply. 3.73. In the year 1972, what is the difference between the Population (in %) of Armenia and Population (in %) of Morocco?
Offer a very short reply. 2.22. In the year 1972, what is the difference between the Population (in %) of Armenia and Population (in %) of Tunisia?
Provide a succinct answer. 2.13. In the year 1972, what is the difference between the Population (in %) in Morocco and Population (in %) in Tunisia?
Offer a very short reply. -0.09. In the year 1973, what is the difference between the Population (in %) in Argentina and Population (in %) in Armenia?
Keep it short and to the point. 1.7. In the year 1973, what is the difference between the Population (in %) in Argentina and Population (in %) in Morocco?
Provide a short and direct response. 3.95. In the year 1973, what is the difference between the Population (in %) of Argentina and Population (in %) of Tunisia?
Offer a very short reply. 3.83. In the year 1973, what is the difference between the Population (in %) in Armenia and Population (in %) in Morocco?
Offer a very short reply. 2.25. In the year 1973, what is the difference between the Population (in %) in Armenia and Population (in %) in Tunisia?
Keep it short and to the point. 2.13. In the year 1973, what is the difference between the Population (in %) in Morocco and Population (in %) in Tunisia?
Your answer should be compact. -0.12. In the year 1974, what is the difference between the Population (in %) of Argentina and Population (in %) of Armenia?
Your answer should be compact. 1.78. In the year 1974, what is the difference between the Population (in %) of Argentina and Population (in %) of Morocco?
Keep it short and to the point. 4.08. In the year 1974, what is the difference between the Population (in %) in Argentina and Population (in %) in Tunisia?
Give a very brief answer. 3.92. In the year 1974, what is the difference between the Population (in %) in Armenia and Population (in %) in Morocco?
Give a very brief answer. 2.29. In the year 1974, what is the difference between the Population (in %) of Armenia and Population (in %) of Tunisia?
Keep it short and to the point. 2.13. In the year 1974, what is the difference between the Population (in %) in Morocco and Population (in %) in Tunisia?
Ensure brevity in your answer.  -0.16. In the year 1975, what is the difference between the Population (in %) of Argentina and Population (in %) of Armenia?
Your answer should be compact. 1.84. In the year 1975, what is the difference between the Population (in %) in Argentina and Population (in %) in Morocco?
Provide a short and direct response. 4.2. In the year 1975, what is the difference between the Population (in %) in Argentina and Population (in %) in Tunisia?
Ensure brevity in your answer.  3.99. In the year 1975, what is the difference between the Population (in %) in Armenia and Population (in %) in Morocco?
Your answer should be very brief. 2.36. In the year 1975, what is the difference between the Population (in %) in Armenia and Population (in %) in Tunisia?
Make the answer very short. 2.15. In the year 1975, what is the difference between the Population (in %) of Morocco and Population (in %) of Tunisia?
Offer a very short reply. -0.21. What is the ratio of the Population (in %) of Argentina in 1968 to that in 1969?
Your answer should be very brief. 0.98. What is the ratio of the Population (in %) in Morocco in 1968 to that in 1969?
Offer a very short reply. 0.99. What is the ratio of the Population (in %) of Tunisia in 1968 to that in 1969?
Your answer should be very brief. 1. What is the ratio of the Population (in %) of Argentina in 1968 to that in 1970?
Your response must be concise. 0.96. What is the ratio of the Population (in %) of Armenia in 1968 to that in 1970?
Offer a terse response. 0.98. What is the ratio of the Population (in %) of Morocco in 1968 to that in 1970?
Make the answer very short. 0.98. What is the ratio of the Population (in %) in Tunisia in 1968 to that in 1970?
Your answer should be very brief. 1.01. What is the ratio of the Population (in %) in Argentina in 1968 to that in 1971?
Your answer should be compact. 0.94. What is the ratio of the Population (in %) in Armenia in 1968 to that in 1971?
Give a very brief answer. 0.97. What is the ratio of the Population (in %) in Morocco in 1968 to that in 1971?
Your answer should be compact. 0.97. What is the ratio of the Population (in %) of Tunisia in 1968 to that in 1971?
Provide a short and direct response. 0.99. What is the ratio of the Population (in %) of Argentina in 1968 to that in 1972?
Ensure brevity in your answer.  0.92. What is the ratio of the Population (in %) in Armenia in 1968 to that in 1972?
Give a very brief answer. 0.96. What is the ratio of the Population (in %) in Morocco in 1968 to that in 1972?
Provide a succinct answer. 0.97. What is the ratio of the Population (in %) in Tunisia in 1968 to that in 1972?
Ensure brevity in your answer.  0.98. What is the ratio of the Population (in %) of Argentina in 1968 to that in 1973?
Ensure brevity in your answer.  0.91. What is the ratio of the Population (in %) of Armenia in 1968 to that in 1973?
Offer a terse response. 0.95. What is the ratio of the Population (in %) in Morocco in 1968 to that in 1973?
Ensure brevity in your answer.  0.96. What is the ratio of the Population (in %) in Tunisia in 1968 to that in 1973?
Provide a succinct answer. 0.97. What is the ratio of the Population (in %) of Argentina in 1968 to that in 1974?
Give a very brief answer. 0.89. What is the ratio of the Population (in %) in Armenia in 1968 to that in 1974?
Make the answer very short. 0.95. What is the ratio of the Population (in %) in Morocco in 1968 to that in 1974?
Offer a terse response. 0.97. What is the ratio of the Population (in %) of Tunisia in 1968 to that in 1974?
Provide a succinct answer. 0.96. What is the ratio of the Population (in %) of Argentina in 1968 to that in 1975?
Provide a short and direct response. 0.88. What is the ratio of the Population (in %) in Armenia in 1968 to that in 1975?
Offer a very short reply. 0.94. What is the ratio of the Population (in %) of Tunisia in 1968 to that in 1975?
Keep it short and to the point. 0.96. What is the ratio of the Population (in %) in Argentina in 1969 to that in 1970?
Offer a very short reply. 0.98. What is the ratio of the Population (in %) in Morocco in 1969 to that in 1970?
Your answer should be compact. 0.99. What is the ratio of the Population (in %) in Argentina in 1969 to that in 1971?
Provide a succinct answer. 0.96. What is the ratio of the Population (in %) of Armenia in 1969 to that in 1971?
Give a very brief answer. 0.98. What is the ratio of the Population (in %) in Morocco in 1969 to that in 1971?
Give a very brief answer. 0.98. What is the ratio of the Population (in %) in Tunisia in 1969 to that in 1971?
Your answer should be very brief. 0.99. What is the ratio of the Population (in %) of Argentina in 1969 to that in 1972?
Ensure brevity in your answer.  0.94. What is the ratio of the Population (in %) in Armenia in 1969 to that in 1972?
Give a very brief answer. 0.97. What is the ratio of the Population (in %) of Morocco in 1969 to that in 1972?
Your response must be concise. 0.98. What is the ratio of the Population (in %) of Tunisia in 1969 to that in 1972?
Give a very brief answer. 0.98. What is the ratio of the Population (in %) in Argentina in 1969 to that in 1973?
Ensure brevity in your answer.  0.93. What is the ratio of the Population (in %) in Armenia in 1969 to that in 1973?
Offer a terse response. 0.96. What is the ratio of the Population (in %) in Morocco in 1969 to that in 1973?
Offer a terse response. 0.98. What is the ratio of the Population (in %) of Tunisia in 1969 to that in 1973?
Provide a succinct answer. 0.97. What is the ratio of the Population (in %) in Argentina in 1969 to that in 1974?
Your answer should be very brief. 0.91. What is the ratio of the Population (in %) of Armenia in 1969 to that in 1974?
Ensure brevity in your answer.  0.96. What is the ratio of the Population (in %) of Morocco in 1969 to that in 1974?
Provide a succinct answer. 0.98. What is the ratio of the Population (in %) in Tunisia in 1969 to that in 1974?
Your answer should be compact. 0.96. What is the ratio of the Population (in %) in Argentina in 1969 to that in 1975?
Offer a very short reply. 0.9. What is the ratio of the Population (in %) of Armenia in 1969 to that in 1975?
Give a very brief answer. 0.95. What is the ratio of the Population (in %) in Morocco in 1969 to that in 1975?
Provide a succinct answer. 0.99. What is the ratio of the Population (in %) of Tunisia in 1969 to that in 1975?
Give a very brief answer. 0.95. What is the ratio of the Population (in %) in Argentina in 1970 to that in 1971?
Provide a short and direct response. 0.98. What is the ratio of the Population (in %) of Armenia in 1970 to that in 1971?
Keep it short and to the point. 0.99. What is the ratio of the Population (in %) in Tunisia in 1970 to that in 1971?
Keep it short and to the point. 0.99. What is the ratio of the Population (in %) in Argentina in 1970 to that in 1972?
Offer a terse response. 0.96. What is the ratio of the Population (in %) of Armenia in 1970 to that in 1972?
Give a very brief answer. 0.98. What is the ratio of the Population (in %) of Morocco in 1970 to that in 1972?
Give a very brief answer. 0.99. What is the ratio of the Population (in %) of Tunisia in 1970 to that in 1972?
Your answer should be very brief. 0.97. What is the ratio of the Population (in %) of Argentina in 1970 to that in 1973?
Keep it short and to the point. 0.94. What is the ratio of the Population (in %) in Armenia in 1970 to that in 1973?
Offer a terse response. 0.97. What is the ratio of the Population (in %) in Morocco in 1970 to that in 1973?
Keep it short and to the point. 0.99. What is the ratio of the Population (in %) of Tunisia in 1970 to that in 1973?
Keep it short and to the point. 0.97. What is the ratio of the Population (in %) in Argentina in 1970 to that in 1974?
Ensure brevity in your answer.  0.93. What is the ratio of the Population (in %) of Armenia in 1970 to that in 1974?
Offer a very short reply. 0.97. What is the ratio of the Population (in %) of Morocco in 1970 to that in 1974?
Offer a terse response. 0.99. What is the ratio of the Population (in %) in Tunisia in 1970 to that in 1974?
Ensure brevity in your answer.  0.96. What is the ratio of the Population (in %) of Argentina in 1970 to that in 1975?
Keep it short and to the point. 0.92. What is the ratio of the Population (in %) of Armenia in 1970 to that in 1975?
Provide a succinct answer. 0.96. What is the ratio of the Population (in %) of Morocco in 1970 to that in 1975?
Your response must be concise. 1. What is the ratio of the Population (in %) of Tunisia in 1970 to that in 1975?
Keep it short and to the point. 0.95. What is the ratio of the Population (in %) of Argentina in 1971 to that in 1972?
Give a very brief answer. 0.98. What is the ratio of the Population (in %) in Morocco in 1971 to that in 1972?
Ensure brevity in your answer.  1. What is the ratio of the Population (in %) of Tunisia in 1971 to that in 1972?
Give a very brief answer. 0.99. What is the ratio of the Population (in %) of Argentina in 1971 to that in 1973?
Ensure brevity in your answer.  0.96. What is the ratio of the Population (in %) of Armenia in 1971 to that in 1973?
Ensure brevity in your answer.  0.99. What is the ratio of the Population (in %) in Morocco in 1971 to that in 1973?
Provide a short and direct response. 0.99. What is the ratio of the Population (in %) in Tunisia in 1971 to that in 1973?
Provide a short and direct response. 0.98. What is the ratio of the Population (in %) in Argentina in 1971 to that in 1974?
Give a very brief answer. 0.95. What is the ratio of the Population (in %) in Armenia in 1971 to that in 1974?
Ensure brevity in your answer.  0.98. What is the ratio of the Population (in %) in Tunisia in 1971 to that in 1974?
Your answer should be very brief. 0.97. What is the ratio of the Population (in %) in Argentina in 1971 to that in 1975?
Give a very brief answer. 0.94. What is the ratio of the Population (in %) in Armenia in 1971 to that in 1975?
Make the answer very short. 0.97. What is the ratio of the Population (in %) in Tunisia in 1971 to that in 1975?
Make the answer very short. 0.96. What is the ratio of the Population (in %) in Argentina in 1972 to that in 1973?
Keep it short and to the point. 0.98. What is the ratio of the Population (in %) in Armenia in 1972 to that in 1973?
Provide a succinct answer. 0.99. What is the ratio of the Population (in %) in Morocco in 1972 to that in 1973?
Ensure brevity in your answer.  1. What is the ratio of the Population (in %) of Tunisia in 1972 to that in 1973?
Keep it short and to the point. 0.99. What is the ratio of the Population (in %) of Armenia in 1972 to that in 1974?
Give a very brief answer. 0.99. What is the ratio of the Population (in %) of Tunisia in 1972 to that in 1974?
Your answer should be very brief. 0.98. What is the ratio of the Population (in %) of Argentina in 1972 to that in 1975?
Offer a terse response. 0.95. What is the ratio of the Population (in %) in Armenia in 1972 to that in 1975?
Give a very brief answer. 0.98. What is the ratio of the Population (in %) of Morocco in 1972 to that in 1975?
Your answer should be very brief. 1.01. What is the ratio of the Population (in %) of Tunisia in 1972 to that in 1975?
Offer a very short reply. 0.98. What is the ratio of the Population (in %) of Argentina in 1973 to that in 1974?
Keep it short and to the point. 0.98. What is the ratio of the Population (in %) of Armenia in 1973 to that in 1974?
Your answer should be compact. 0.99. What is the ratio of the Population (in %) in Tunisia in 1973 to that in 1974?
Your answer should be compact. 0.99. What is the ratio of the Population (in %) of Armenia in 1973 to that in 1975?
Offer a terse response. 0.99. What is the ratio of the Population (in %) in Morocco in 1973 to that in 1975?
Ensure brevity in your answer.  1.01. What is the ratio of the Population (in %) of Argentina in 1974 to that in 1975?
Offer a terse response. 0.99. What is the difference between the highest and the second highest Population (in %) of Argentina?
Your response must be concise. 0.11. What is the difference between the highest and the second highest Population (in %) of Armenia?
Your answer should be compact. 0.04. What is the difference between the highest and the second highest Population (in %) of Morocco?
Your answer should be very brief. 0. What is the difference between the highest and the second highest Population (in %) in Tunisia?
Your response must be concise. 0.03. What is the difference between the highest and the lowest Population (in %) in Argentina?
Your answer should be compact. 0.92. What is the difference between the highest and the lowest Population (in %) of Armenia?
Offer a very short reply. 0.34. What is the difference between the highest and the lowest Population (in %) of Morocco?
Give a very brief answer. 0.12. What is the difference between the highest and the lowest Population (in %) of Tunisia?
Your answer should be very brief. 0.18. 